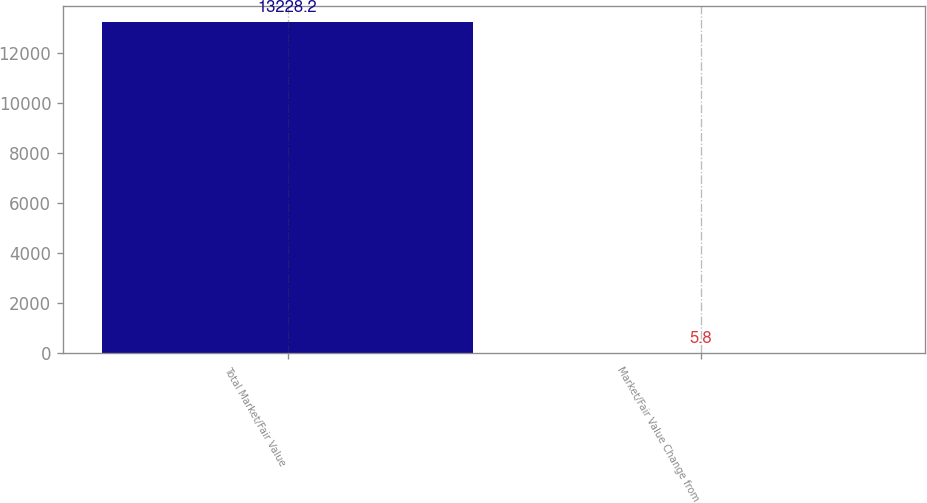<chart> <loc_0><loc_0><loc_500><loc_500><bar_chart><fcel>Total Market/Fair Value<fcel>Market/Fair Value Change from<nl><fcel>13228.2<fcel>5.8<nl></chart> 